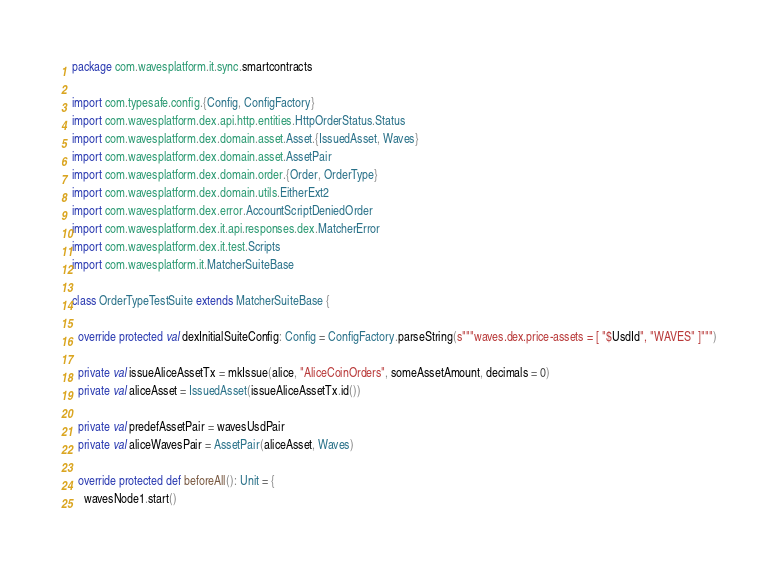Convert code to text. <code><loc_0><loc_0><loc_500><loc_500><_Scala_>package com.wavesplatform.it.sync.smartcontracts

import com.typesafe.config.{Config, ConfigFactory}
import com.wavesplatform.dex.api.http.entities.HttpOrderStatus.Status
import com.wavesplatform.dex.domain.asset.Asset.{IssuedAsset, Waves}
import com.wavesplatform.dex.domain.asset.AssetPair
import com.wavesplatform.dex.domain.order.{Order, OrderType}
import com.wavesplatform.dex.domain.utils.EitherExt2
import com.wavesplatform.dex.error.AccountScriptDeniedOrder
import com.wavesplatform.dex.it.api.responses.dex.MatcherError
import com.wavesplatform.dex.it.test.Scripts
import com.wavesplatform.it.MatcherSuiteBase

class OrderTypeTestSuite extends MatcherSuiteBase {

  override protected val dexInitialSuiteConfig: Config = ConfigFactory.parseString(s"""waves.dex.price-assets = [ "$UsdId", "WAVES" ]""")

  private val issueAliceAssetTx = mkIssue(alice, "AliceCoinOrders", someAssetAmount, decimals = 0)
  private val aliceAsset = IssuedAsset(issueAliceAssetTx.id())

  private val predefAssetPair = wavesUsdPair
  private val aliceWavesPair = AssetPair(aliceAsset, Waves)

  override protected def beforeAll(): Unit = {
    wavesNode1.start()</code> 